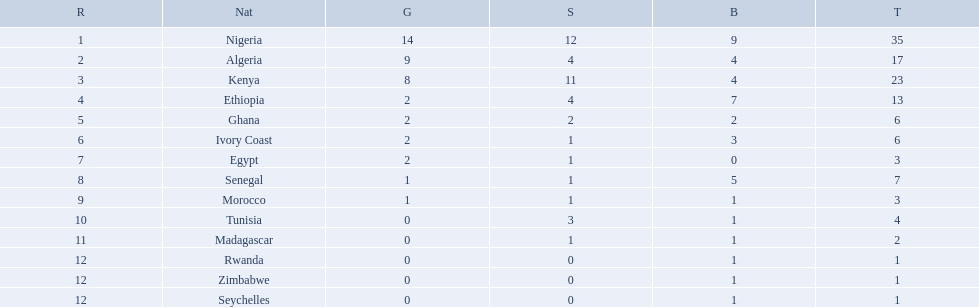What nations competed at the 1989 african championships in athletics? Nigeria, Algeria, Kenya, Ethiopia, Ghana, Ivory Coast, Egypt, Senegal, Morocco, Tunisia, Madagascar, Rwanda, Zimbabwe, Seychelles. What nations earned bronze medals? Nigeria, Algeria, Kenya, Ethiopia, Ghana, Ivory Coast, Senegal, Morocco, Tunisia, Madagascar, Rwanda, Zimbabwe, Seychelles. What nation did not earn a bronze medal? Egypt. 